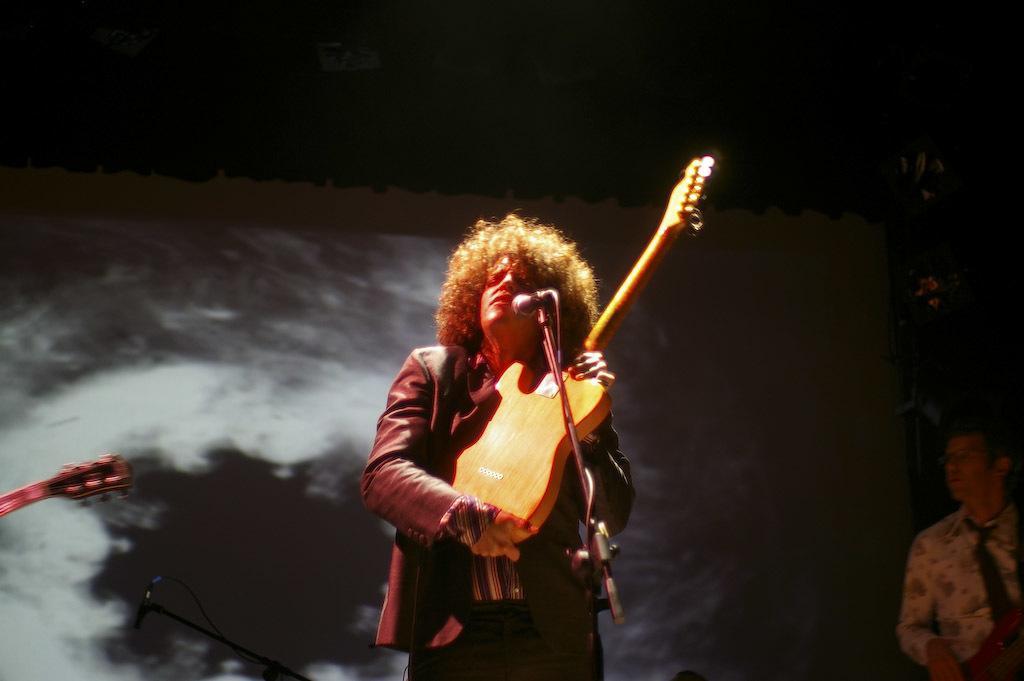How would you summarize this image in a sentence or two? In the center we can see the man he is holding guitar. In front of him we can see the microphone. Coming to the background we can see the screen. On the right side we can see the man standing. 